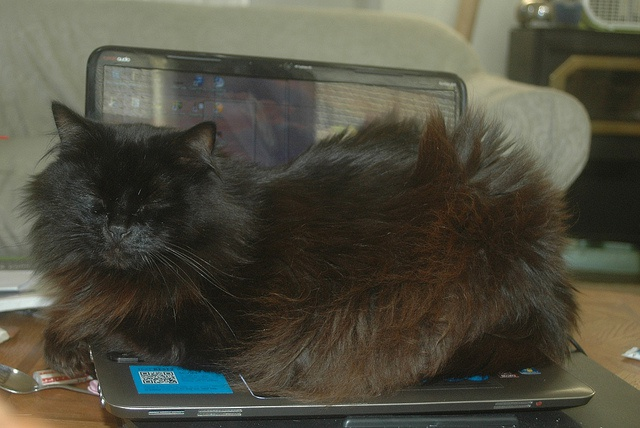Describe the objects in this image and their specific colors. I can see cat in gray and black tones, laptop in gray and black tones, couch in gray and darkgray tones, and spoon in gray and darkgray tones in this image. 